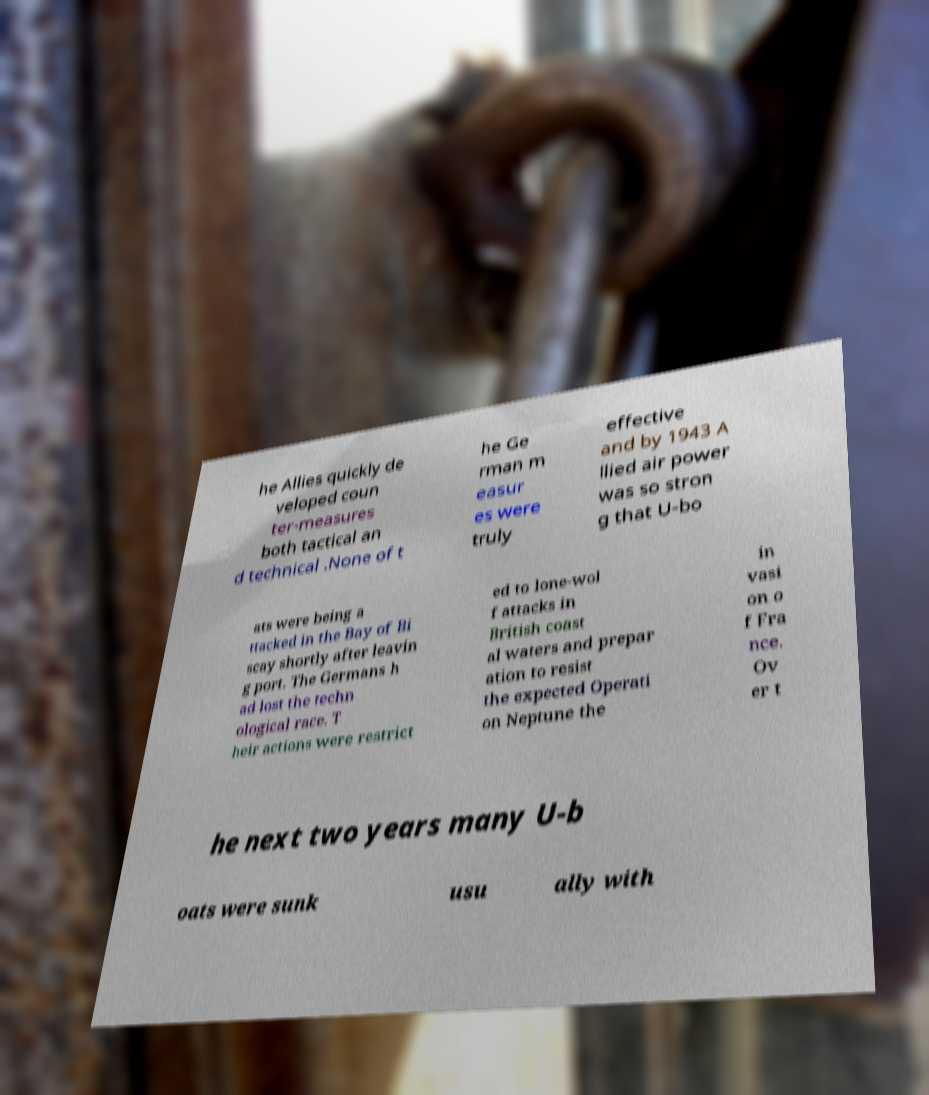Please identify and transcribe the text found in this image. he Allies quickly de veloped coun ter-measures both tactical an d technical .None of t he Ge rman m easur es were truly effective and by 1943 A llied air power was so stron g that U-bo ats were being a ttacked in the Bay of Bi scay shortly after leavin g port. The Germans h ad lost the techn ological race. T heir actions were restrict ed to lone-wol f attacks in British coast al waters and prepar ation to resist the expected Operati on Neptune the in vasi on o f Fra nce. Ov er t he next two years many U-b oats were sunk usu ally with 